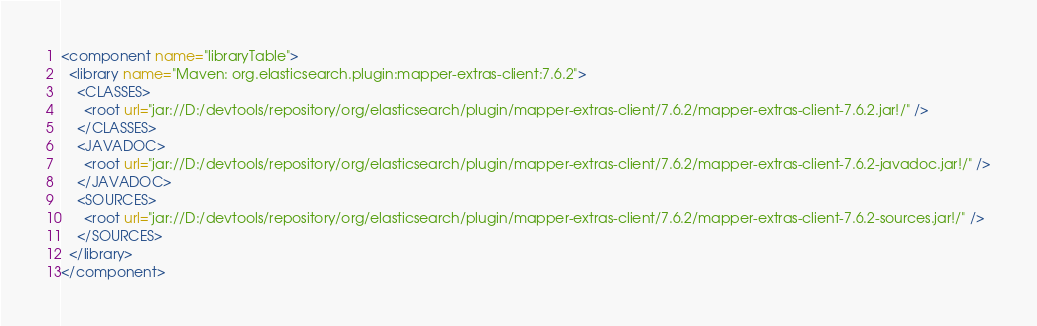<code> <loc_0><loc_0><loc_500><loc_500><_XML_><component name="libraryTable">
  <library name="Maven: org.elasticsearch.plugin:mapper-extras-client:7.6.2">
    <CLASSES>
      <root url="jar://D:/devtools/repository/org/elasticsearch/plugin/mapper-extras-client/7.6.2/mapper-extras-client-7.6.2.jar!/" />
    </CLASSES>
    <JAVADOC>
      <root url="jar://D:/devtools/repository/org/elasticsearch/plugin/mapper-extras-client/7.6.2/mapper-extras-client-7.6.2-javadoc.jar!/" />
    </JAVADOC>
    <SOURCES>
      <root url="jar://D:/devtools/repository/org/elasticsearch/plugin/mapper-extras-client/7.6.2/mapper-extras-client-7.6.2-sources.jar!/" />
    </SOURCES>
  </library>
</component></code> 